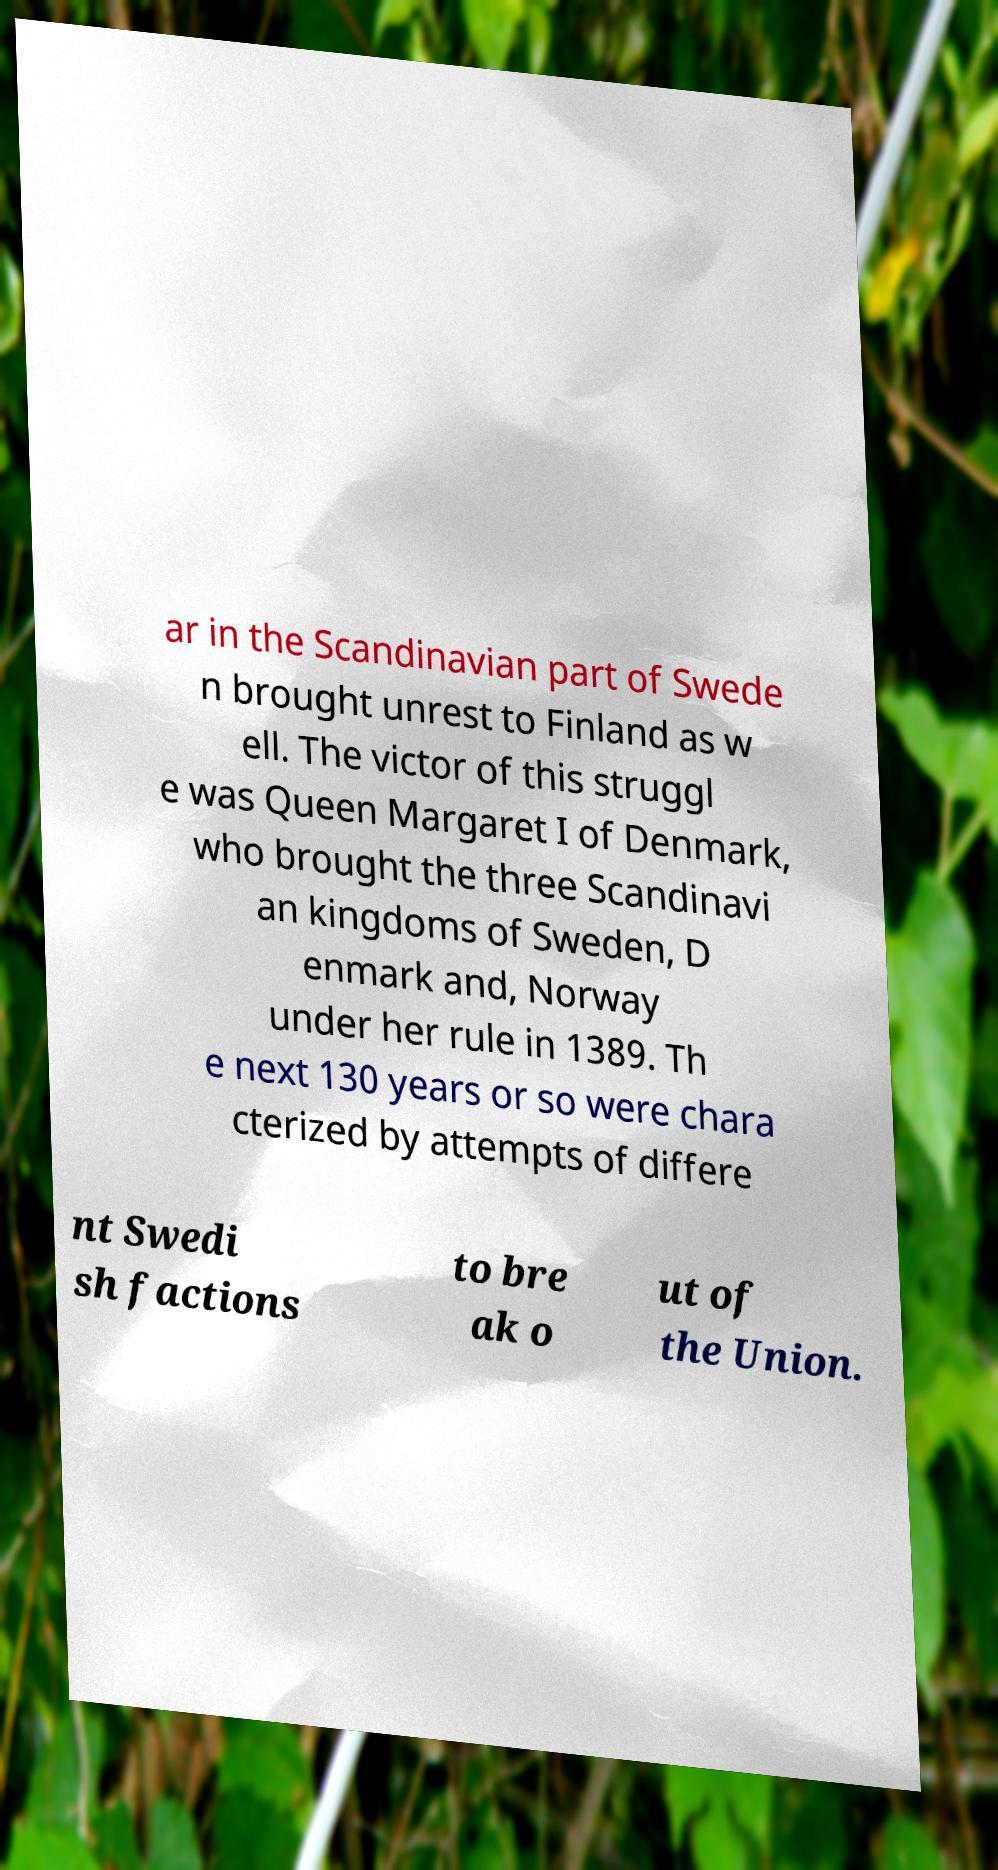I need the written content from this picture converted into text. Can you do that? ar in the Scandinavian part of Swede n brought unrest to Finland as w ell. The victor of this struggl e was Queen Margaret I of Denmark, who brought the three Scandinavi an kingdoms of Sweden, D enmark and, Norway under her rule in 1389. Th e next 130 years or so were chara cterized by attempts of differe nt Swedi sh factions to bre ak o ut of the Union. 